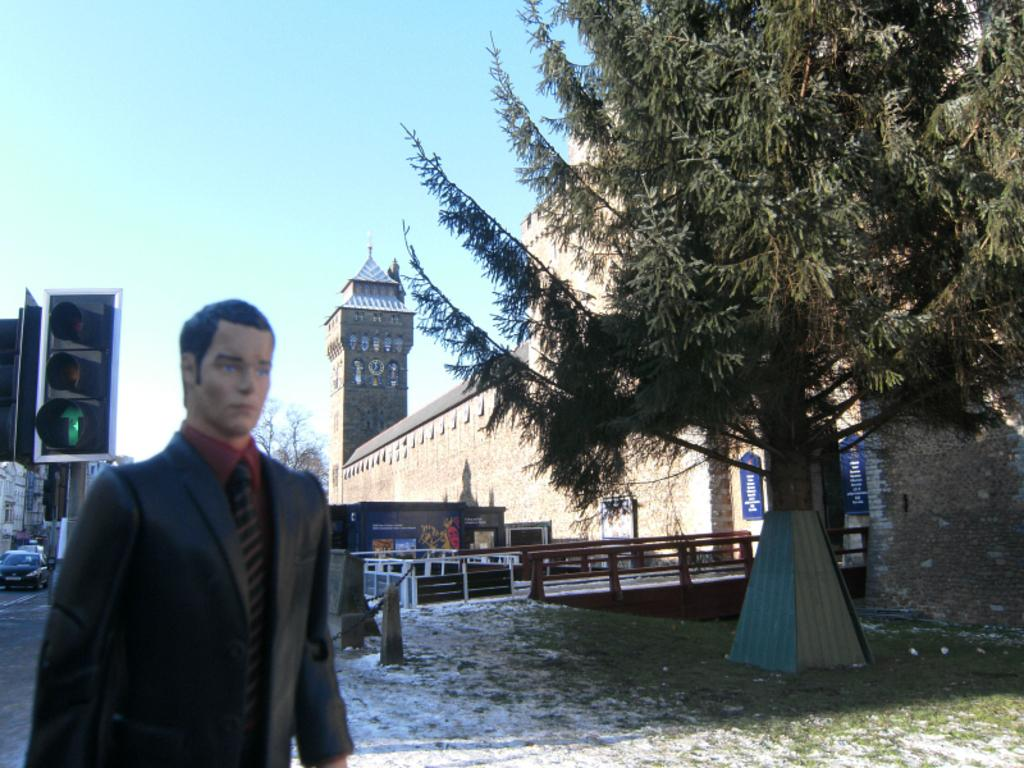What is located on the left side of the image? There is a sculpture and a car on the left side of the image. What can be seen in the image related to traffic control? There is a traffic light in the image. What type of vegetation is on the right side of the image? There is a tree on the right side of the image. What is visible in the background of the image? There is a tower visible in the background of the image. What is visible at the top of the image? The sky is visible at the top of the image. How many clovers are growing on the tree in the image? There is no mention of clovers in the image, and the tree does not appear to have any visible plants growing on it. What type of station is present in the image? There is no station mentioned or visible in the image. 